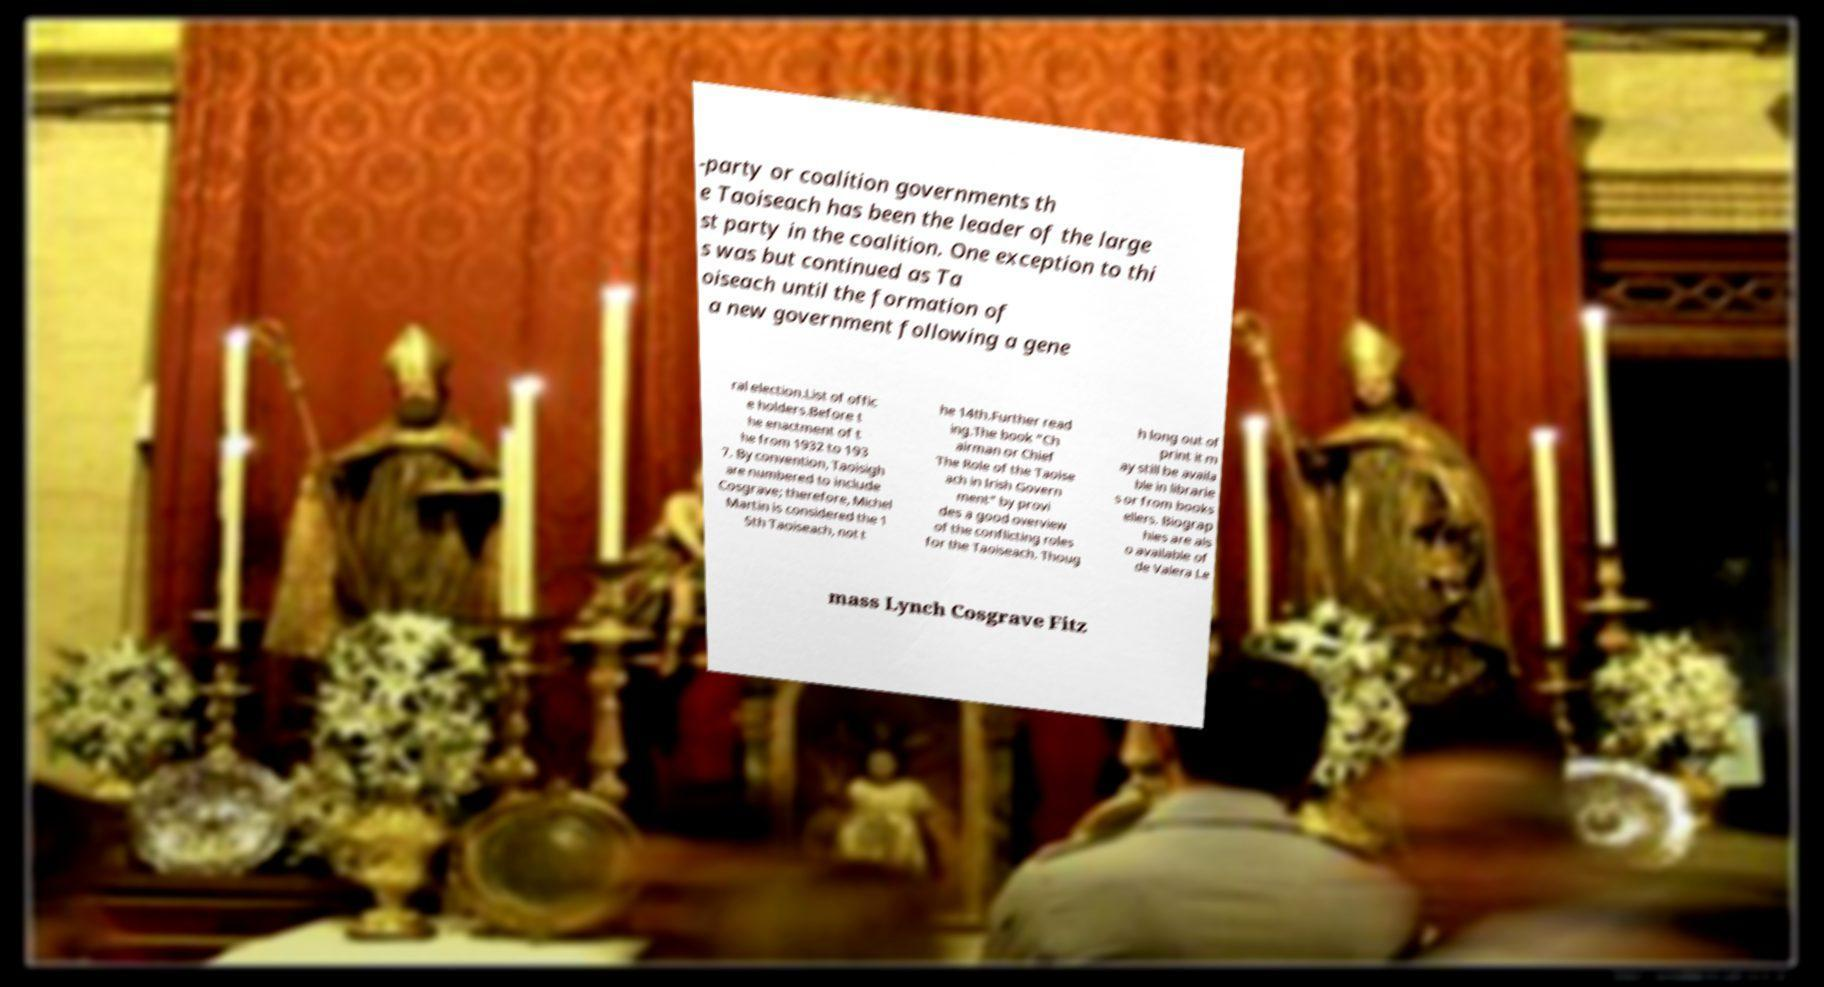I need the written content from this picture converted into text. Can you do that? -party or coalition governments th e Taoiseach has been the leader of the large st party in the coalition. One exception to thi s was but continued as Ta oiseach until the formation of a new government following a gene ral election.List of offic e holders.Before t he enactment of t he from 1932 to 193 7. By convention, Taoisigh are numbered to include Cosgrave; therefore, Michel Martin is considered the 1 5th Taoiseach, not t he 14th.Further read ing.The book "Ch airman or Chief The Role of the Taoise ach in Irish Govern ment" by provi des a good overview of the conflicting roles for the Taoiseach. Thoug h long out of print it m ay still be availa ble in librarie s or from books ellers. Biograp hies are als o available of de Valera Le mass Lynch Cosgrave Fitz 